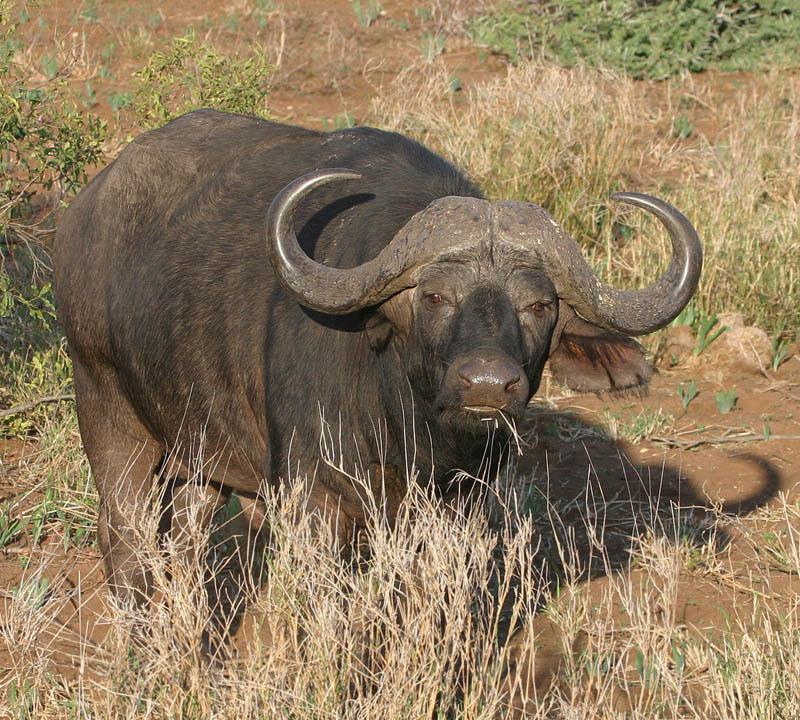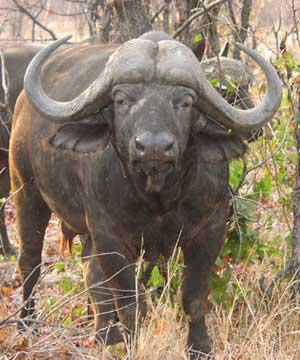The first image is the image on the left, the second image is the image on the right. Evaluate the accuracy of this statement regarding the images: "The left image shows a horned animal in water up to its chest, and the right image shows a buffalo on dry ground.". Is it true? Answer yes or no. No. 